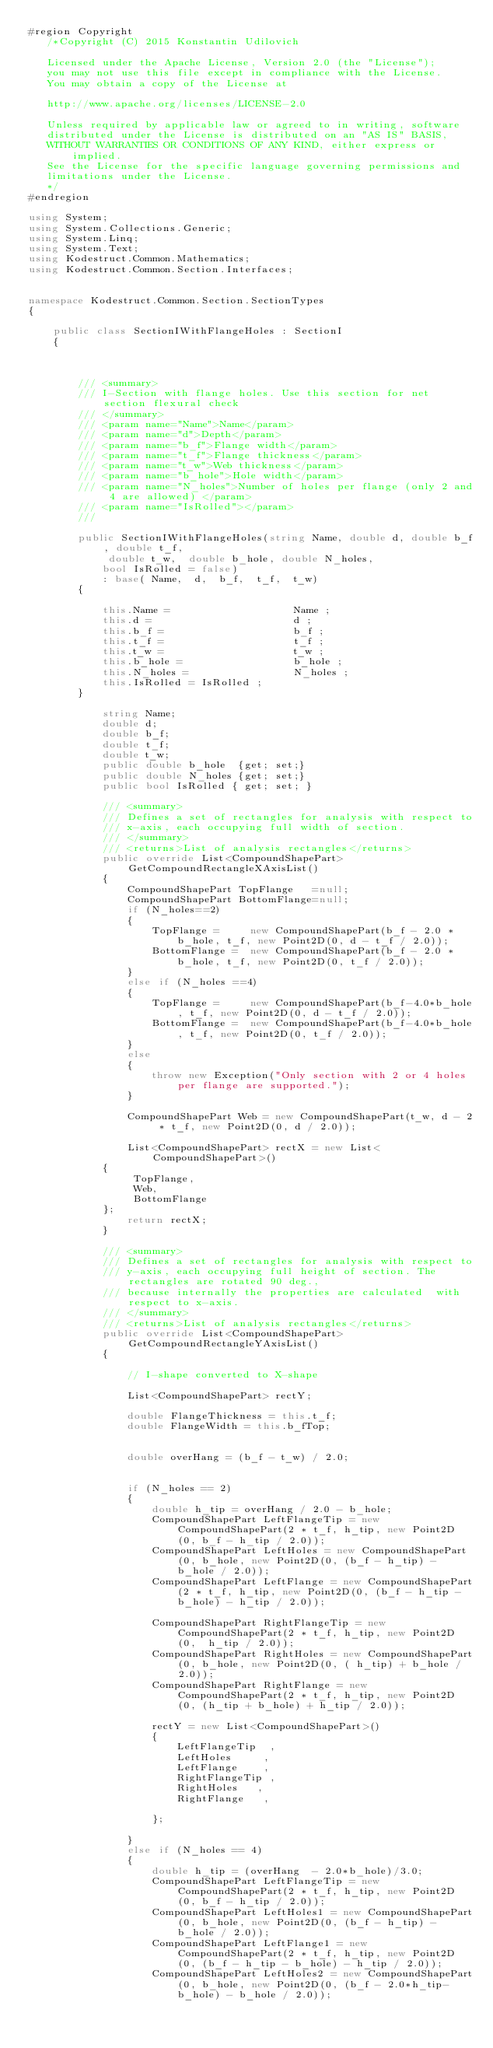Convert code to text. <code><loc_0><loc_0><loc_500><loc_500><_C#_>#region Copyright
   /*Copyright (C) 2015 Konstantin Udilovich

   Licensed under the Apache License, Version 2.0 (the "License");
   you may not use this file except in compliance with the License.
   You may obtain a copy of the License at

   http://www.apache.org/licenses/LICENSE-2.0

   Unless required by applicable law or agreed to in writing, software
   distributed under the License is distributed on an "AS IS" BASIS,
   WITHOUT WARRANTIES OR CONDITIONS OF ANY KIND, either express or implied.
   See the License for the specific language governing permissions and
   limitations under the License.
   */
#endregion
 
using System;
using System.Collections.Generic;
using System.Linq;
using System.Text;
using Kodestruct.Common.Mathematics;
using Kodestruct.Common.Section.Interfaces;


namespace Kodestruct.Common.Section.SectionTypes
{

    public class SectionIWithFlangeHoles : SectionI
    {



        /// <summary>
        /// I-Section with flange holes. Use this section for net section flexural check
        /// </summary>
        /// <param name="Name">Name</param>
        /// <param name="d">Depth</param>
        /// <param name="b_f">Flange width</param>
        /// <param name="t_f">Flange thickness</param>
        /// <param name="t_w">Web thickness</param>
        /// <param name="b_hole">Hole width</param>
        /// <param name="N_holes">Number of holes per flange (only 2 and 4 are allowed) </param>
        /// <param name="IsRolled"></param>
        /// 

        public SectionIWithFlangeHoles(string Name, double d, double b_f, double t_f, 
             double t_w,  double b_hole, double N_holes, 
            bool IsRolled = false)
            : base( Name,  d,  b_f,  t_f,  t_w)
        {

            this.Name =                    Name ; 
            this.d =                       d ; 
            this.b_f =                     b_f ; 
            this.t_f =                     t_f ; 
            this.t_w =                     t_w ; 
            this.b_hole =                  b_hole ; 
            this.N_holes =                 N_holes ;
            this.IsRolled = IsRolled ;
        }

            string Name; 
            double d; 
            double b_f; 
            double t_f; 
            double t_w; 
            public double b_hole  {get; set;}
            public double N_holes {get; set;}
            public bool IsRolled { get; set; }

            /// <summary>
            /// Defines a set of rectangles for analysis with respect to 
            /// x-axis, each occupying full width of section.
            /// </summary>
            /// <returns>List of analysis rectangles</returns>
            public override List<CompoundShapePart> GetCompoundRectangleXAxisList()
            {
                CompoundShapePart TopFlange   =null;
                CompoundShapePart BottomFlange=null;
                if (N_holes==2)
                {
                    TopFlange =     new CompoundShapePart(b_f - 2.0 * b_hole, t_f, new Point2D(0, d - t_f / 2.0));
                    BottomFlange =  new CompoundShapePart(b_f - 2.0 * b_hole, t_f, new Point2D(0, t_f / 2.0));
                }
                else if (N_holes ==4)
                {
                    TopFlange =     new CompoundShapePart(b_f-4.0*b_hole, t_f, new Point2D(0, d - t_f / 2.0));
                    BottomFlange =  new CompoundShapePart(b_f-4.0*b_hole, t_f, new Point2D(0, t_f / 2.0));
                }
                else
                {
                    throw new Exception("Only section with 2 or 4 holes per flange are supported.");
                }

                CompoundShapePart Web = new CompoundShapePart(t_w, d - 2 * t_f, new Point2D(0, d / 2.0));

                List<CompoundShapePart> rectX = new List<CompoundShapePart>()
            {
                 TopFlange,  
                 Web,
                 BottomFlange
            };
                return rectX;
            }

            /// <summary>
            /// Defines a set of rectangles for analysis with respect to 
            /// y-axis, each occupying full height of section. The rectangles are rotated 90 deg., 
            /// because internally the properties are calculated  with respect to x-axis.
            /// </summary>
            /// <returns>List of analysis rectangles</returns>
            public override List<CompoundShapePart> GetCompoundRectangleYAxisList()
            {

                // I-shape converted to X-shape 

                List<CompoundShapePart> rectY;

                double FlangeThickness = this.t_f;
                double FlangeWidth = this.b_fTop;


                double overHang = (b_f - t_w) / 2.0;
                

                if (N_holes == 2)
                {
                    double h_tip = overHang / 2.0 - b_hole;
                    CompoundShapePart LeftFlangeTip = new CompoundShapePart(2 * t_f, h_tip, new Point2D(0, b_f - h_tip / 2.0));
                    CompoundShapePart LeftHoles = new CompoundShapePart(0, b_hole, new Point2D(0, (b_f - h_tip) - b_hole / 2.0));
                    CompoundShapePart LeftFlange = new CompoundShapePart(2 * t_f, h_tip, new Point2D(0, (b_f - h_tip - b_hole) - h_tip / 2.0));

                    CompoundShapePart RightFlangeTip = new CompoundShapePart(2 * t_f, h_tip, new Point2D(0,  h_tip / 2.0));
                    CompoundShapePart RightHoles = new CompoundShapePart(0, b_hole, new Point2D(0, ( h_tip) + b_hole / 2.0));
                    CompoundShapePart RightFlange = new CompoundShapePart(2 * t_f, h_tip, new Point2D(0, (h_tip + b_hole) + h_tip / 2.0));

                    rectY = new List<CompoundShapePart>()
                    {
                        LeftFlangeTip  ,
                        LeftHoles     ,
                        LeftFlange    ,
                        RightFlangeTip ,
                        RightHoles   ,
                        RightFlange   ,

                    };
                
                }
                else if (N_holes == 4)
                {
                    double h_tip = (overHang  - 2.0*b_hole)/3.0;
                    CompoundShapePart LeftFlangeTip = new CompoundShapePart(2 * t_f, h_tip, new Point2D(0, b_f - h_tip / 2.0));
                    CompoundShapePart LeftHoles1 = new CompoundShapePart(0, b_hole, new Point2D(0, (b_f - h_tip) - b_hole / 2.0));
                    CompoundShapePart LeftFlange1 = new CompoundShapePart(2 * t_f, h_tip, new Point2D(0, (b_f - h_tip - b_hole) - h_tip / 2.0));
                    CompoundShapePart LeftHoles2 = new CompoundShapePart(0, b_hole, new Point2D(0, (b_f - 2.0*h_tip-b_hole) - b_hole / 2.0));</code> 